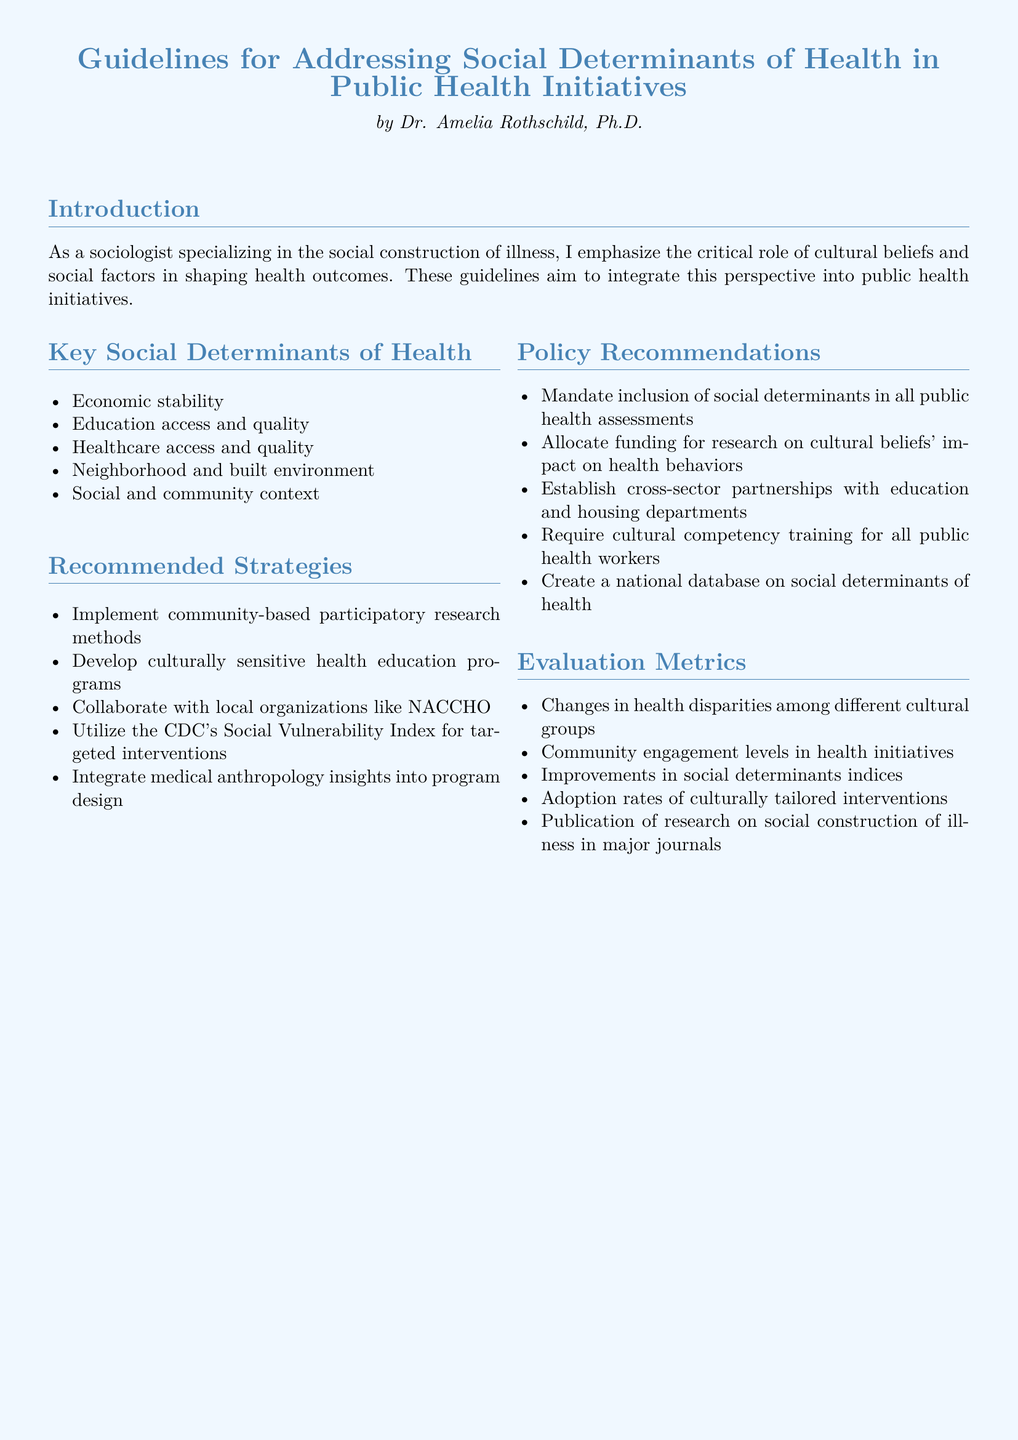What are the key social determinants of health mentioned? The document lists several key social determinants of health, which include economic stability, education access and quality, healthcare access and quality, neighborhood and built environment, and social and community context.
Answer: Economic stability, education access and quality, healthcare access and quality, neighborhood and built environment, social and community context Who is the author of the guidelines? The document attributes the guidelines to Dr. Amelia Rothschild, Ph.D.
Answer: Dr. Amelia Rothschild, Ph.D What is one recommended strategy for public health initiatives? The document provides various recommended strategies, one of which is to implement community-based participatory research methods.
Answer: Implement community-based participatory research methods Which organization is mentioned for collaboration in the recommendations? The document recommends collaboration with local organizations like NACCHO.
Answer: NACCHO What is an evaluation metric listed in the document? Among the evaluation metrics, one listed is changes in health disparities among different cultural groups.
Answer: Changes in health disparities among different cultural groups What type of training is required for public health workers? The document recommends that cultural competency training be required for all public health workers.
Answer: Cultural competency training How many key social determinants of health are listed? The document lists five key social determinants of health.
Answer: Five What type of research funding is suggested in the policy recommendations? The document suggests allocating funding for research on cultural beliefs' impact on health behaviors.
Answer: Research on cultural beliefs' impact on health behaviors 